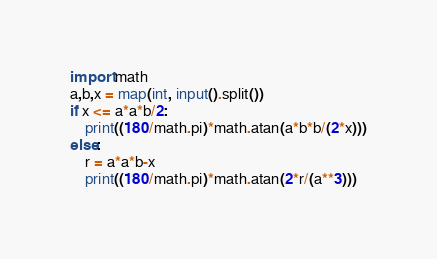<code> <loc_0><loc_0><loc_500><loc_500><_Python_>import math
a,b,x = map(int, input().split())
if x <= a*a*b/2:
    print((180/math.pi)*math.atan(a*b*b/(2*x)))
else:
    r = a*a*b-x
    print((180/math.pi)*math.atan(2*r/(a**3)))</code> 